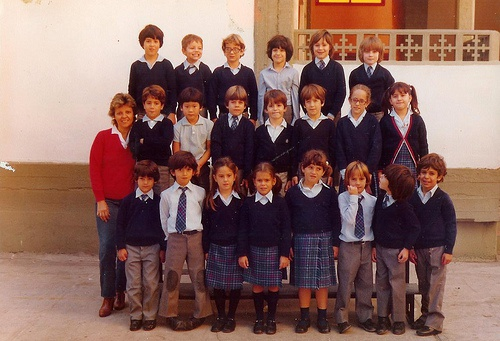Describe the objects in this image and their specific colors. I can see people in beige, black, lightgray, maroon, and brown tones, people in beige, black, maroon, and gray tones, people in beige, black, maroon, and brown tones, people in beige, brown, black, and maroon tones, and people in beige, maroon, black, brown, and darkgray tones in this image. 